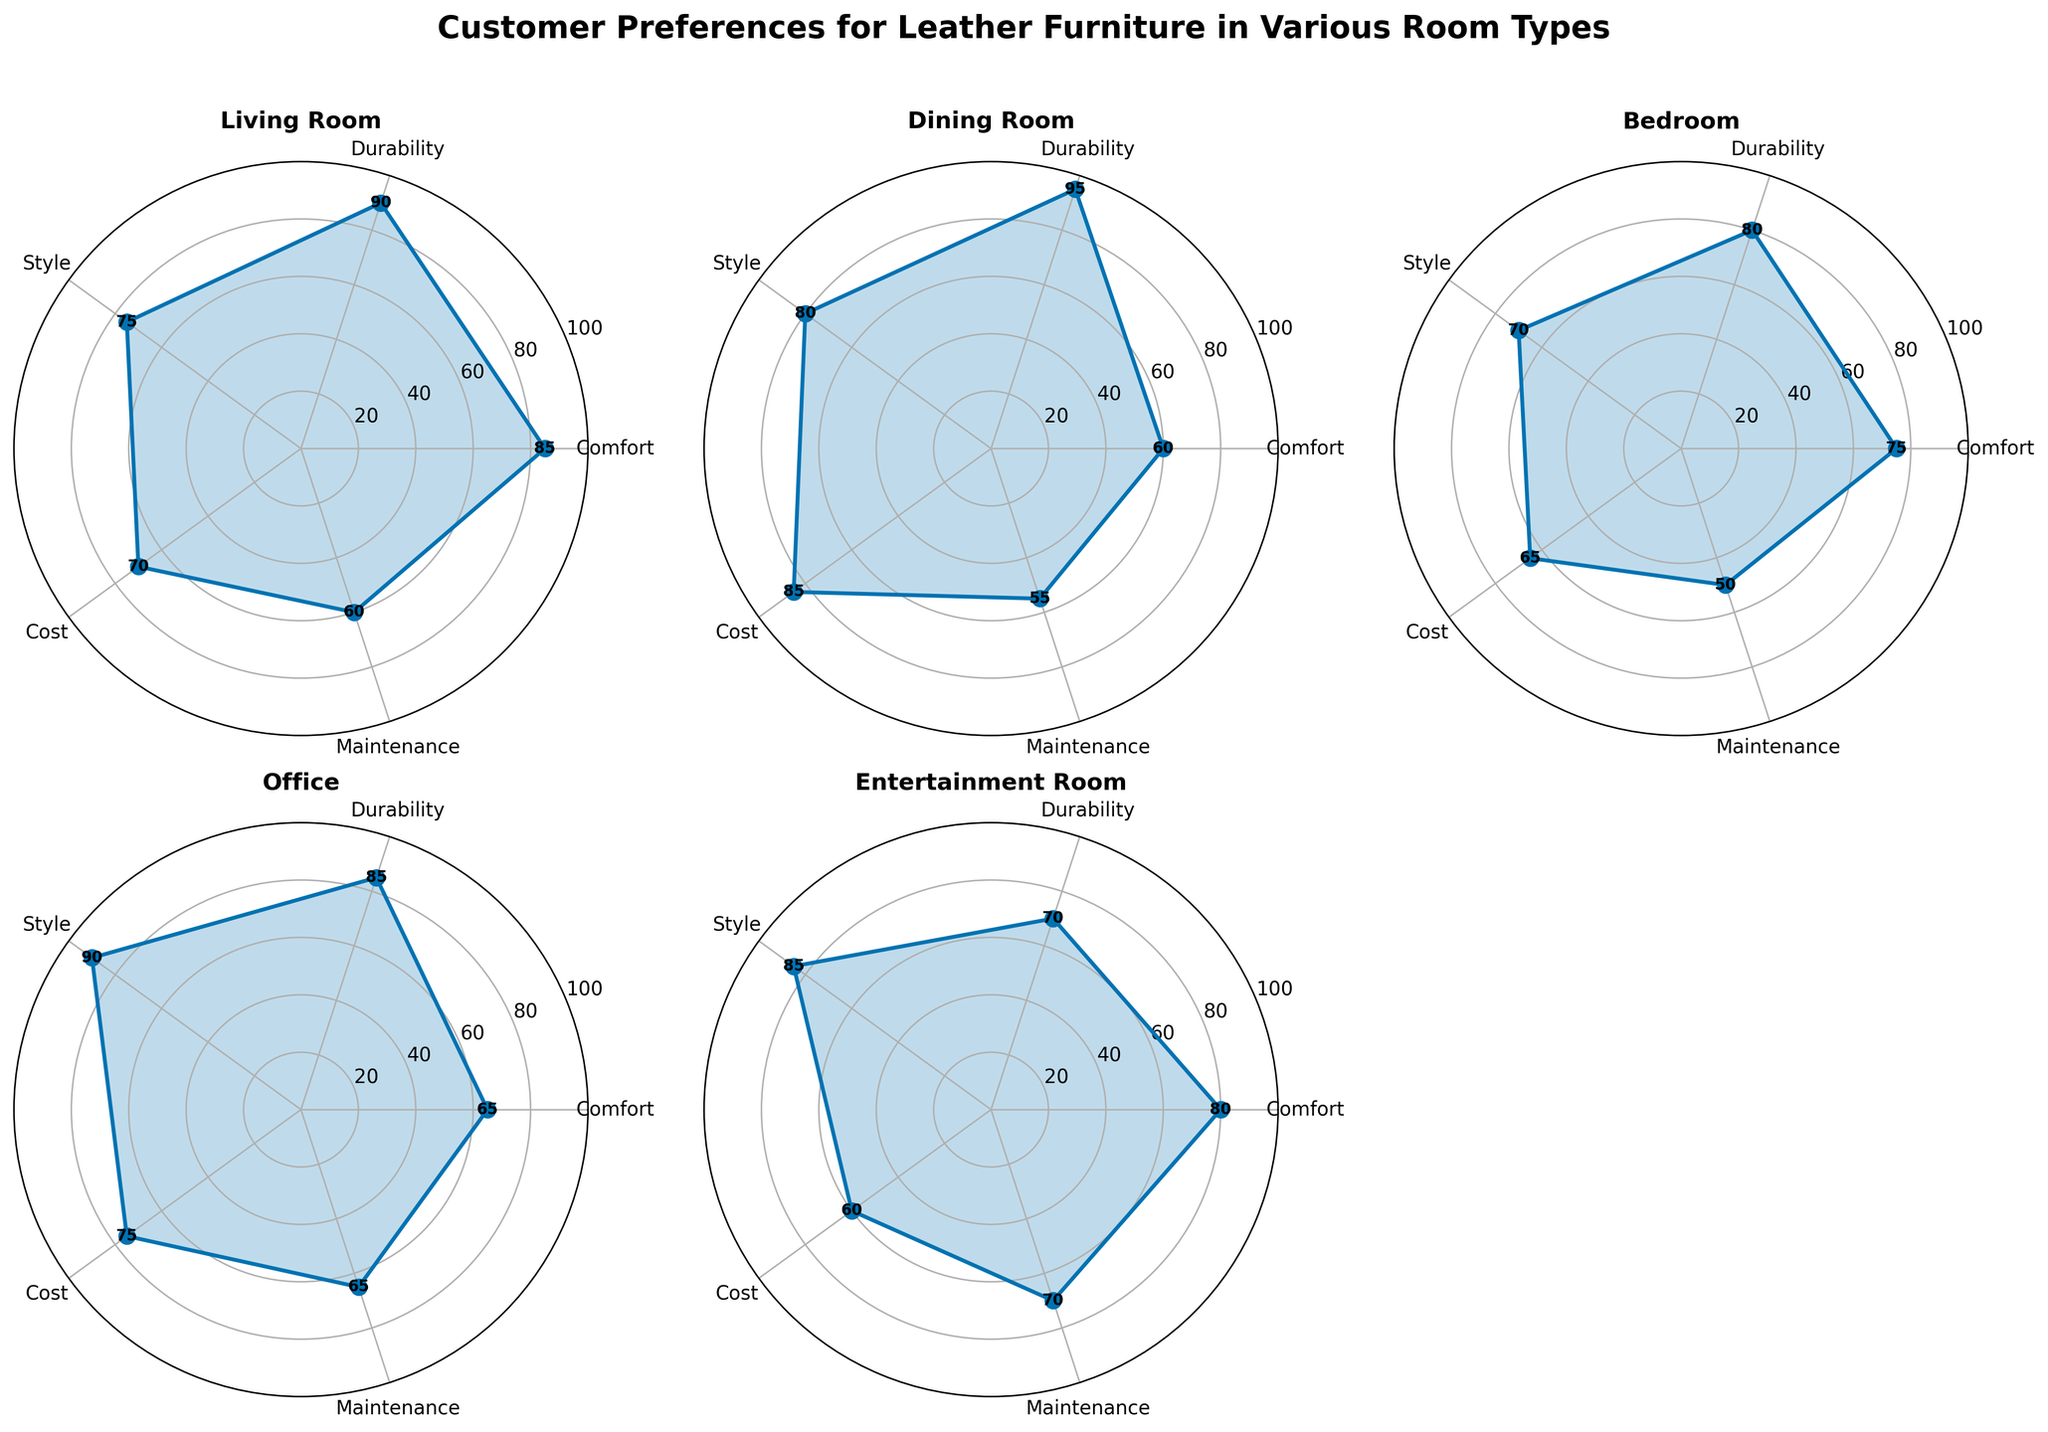What title is given to the entire radar chart subplot figure? The title of the figure is usually displayed at the top in bold and larger fontsize for clarity. In this case, it is "Customer Preferences for Leather Furniture in Various Room Types."
Answer: Customer Preferences for Leather Furniture in Various Room Types Which room type has the highest durability rating? Each radar chart subplot represents a specific room type and shows its ratings in different categories. By examining the durability ratings, the Dining Room chart has the highest durability rating.
Answer: Dining Room What is the median style rating among all room types? The style ratings for all room types are as follows: Living Room (75), Dining Room (80), Bedroom (70), Office (90), and Entertainment Room (85). Arrange them in order to find the median: 70, 75, 80, 85, 90. The middle value is 80.
Answer: 80 Which category has the lowest rating for the Entertainment Room? Check the plotted values for each category in the Entertainment Room radar chart. The lowest rating observed is in the 'Cost' category with a value of 60.
Answer: Cost How does the Bedroom's maintenance rating compare to the Office's? Look at the ratings for maintenance in the Bedroom and Office radar charts. The Bedroom has a maintenance rating of 50, while the Office has a rating of 65. Therefore, the Bedroom's rating is lower.
Answer: Lower Which room type has the highest comfort rating, and what is that rating? Analyze the comfort ratings in each radar chart. The Living Room has the highest comfort rating at 85.
Answer: Living Room, 85 Which room types have a cost rating above 70, and what are those ratings? Check the cost ratings for all room types. The only room type with a rating above 70 is the Dining Room with a rating of 85.
Answer: Dining Room, 85 What is the average durability rating across all rooms? Sum the durability ratings for all room types: Living Room (90), Dining Room (95), Bedroom (80), Office (85), and Entertainment Room (70). Then divide by the number of rooms. (90+95+80+85+70) / 5 = 84
Answer: 84 Which room type has the least variation across its ratings, and how can you identify this? To find the room type with the least variation, examine the range of ratings (difference between highest and lowest values) in each radar chart. The Office has the tightest range from 65 (Maintenance) to 90 (Style), which is a range of 25. This is the smallest variation compared to other rooms.
Answer: Office Which room type emphasizes style over cost the most significantly? Compare the difference between style and cost ratings in each room. The Office shows the most significant emphasis on style over cost, with style being 90 and cost being 75, creating a difference of 15.
Answer: Office 